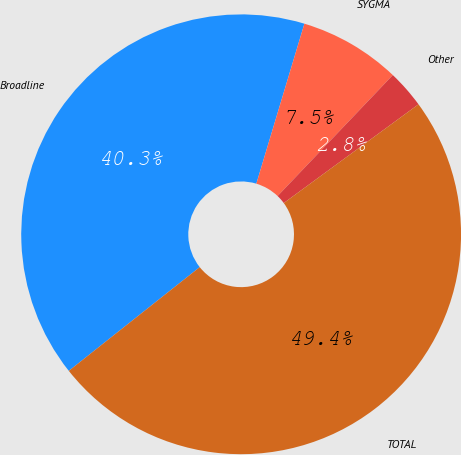Convert chart to OTSL. <chart><loc_0><loc_0><loc_500><loc_500><pie_chart><fcel>Broadline<fcel>SYGMA<fcel>Other<fcel>TOTAL<nl><fcel>40.31%<fcel>7.47%<fcel>2.82%<fcel>49.4%<nl></chart> 